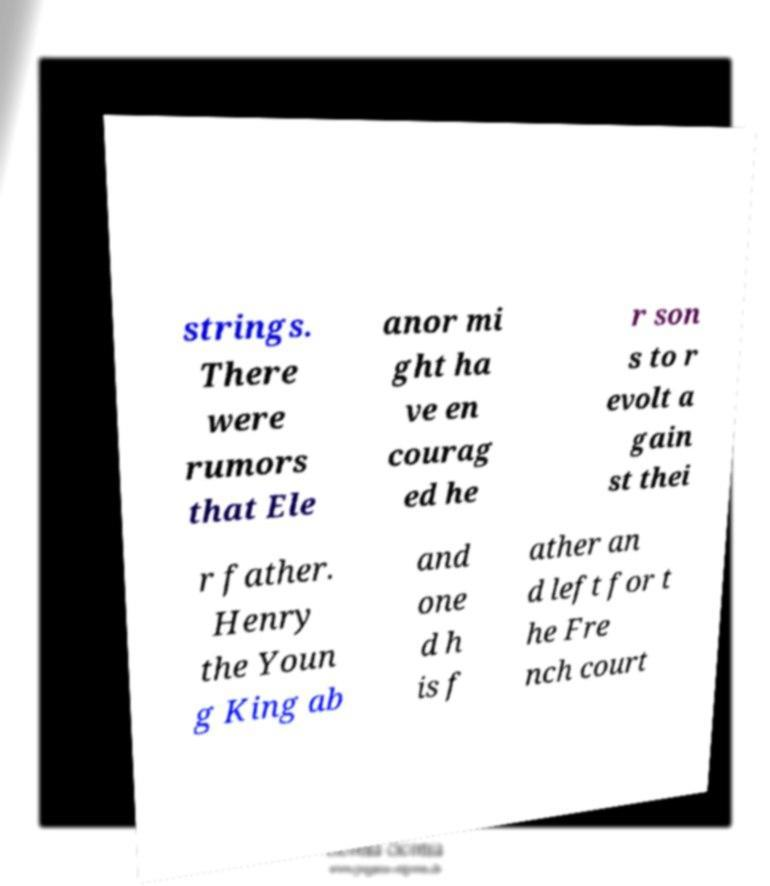Can you read and provide the text displayed in the image?This photo seems to have some interesting text. Can you extract and type it out for me? strings. There were rumors that Ele anor mi ght ha ve en courag ed he r son s to r evolt a gain st thei r father. Henry the Youn g King ab and one d h is f ather an d left for t he Fre nch court 